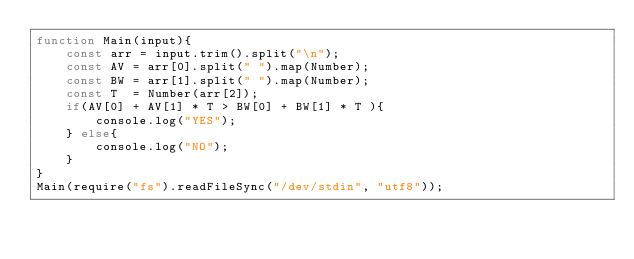Convert code to text. <code><loc_0><loc_0><loc_500><loc_500><_JavaScript_>function Main(input){
    const arr = input.trim().split("\n");
    const AV = arr[0].split(" ").map(Number);
    const BW = arr[1].split(" ").map(Number);
    const T  = Number(arr[2]);
    if(AV[0] + AV[1] * T > BW[0] + BW[1] * T ){
        console.log("YES");
    } else{
        console.log("NO");
    }
}
Main(require("fs").readFileSync("/dev/stdin", "utf8"));
</code> 